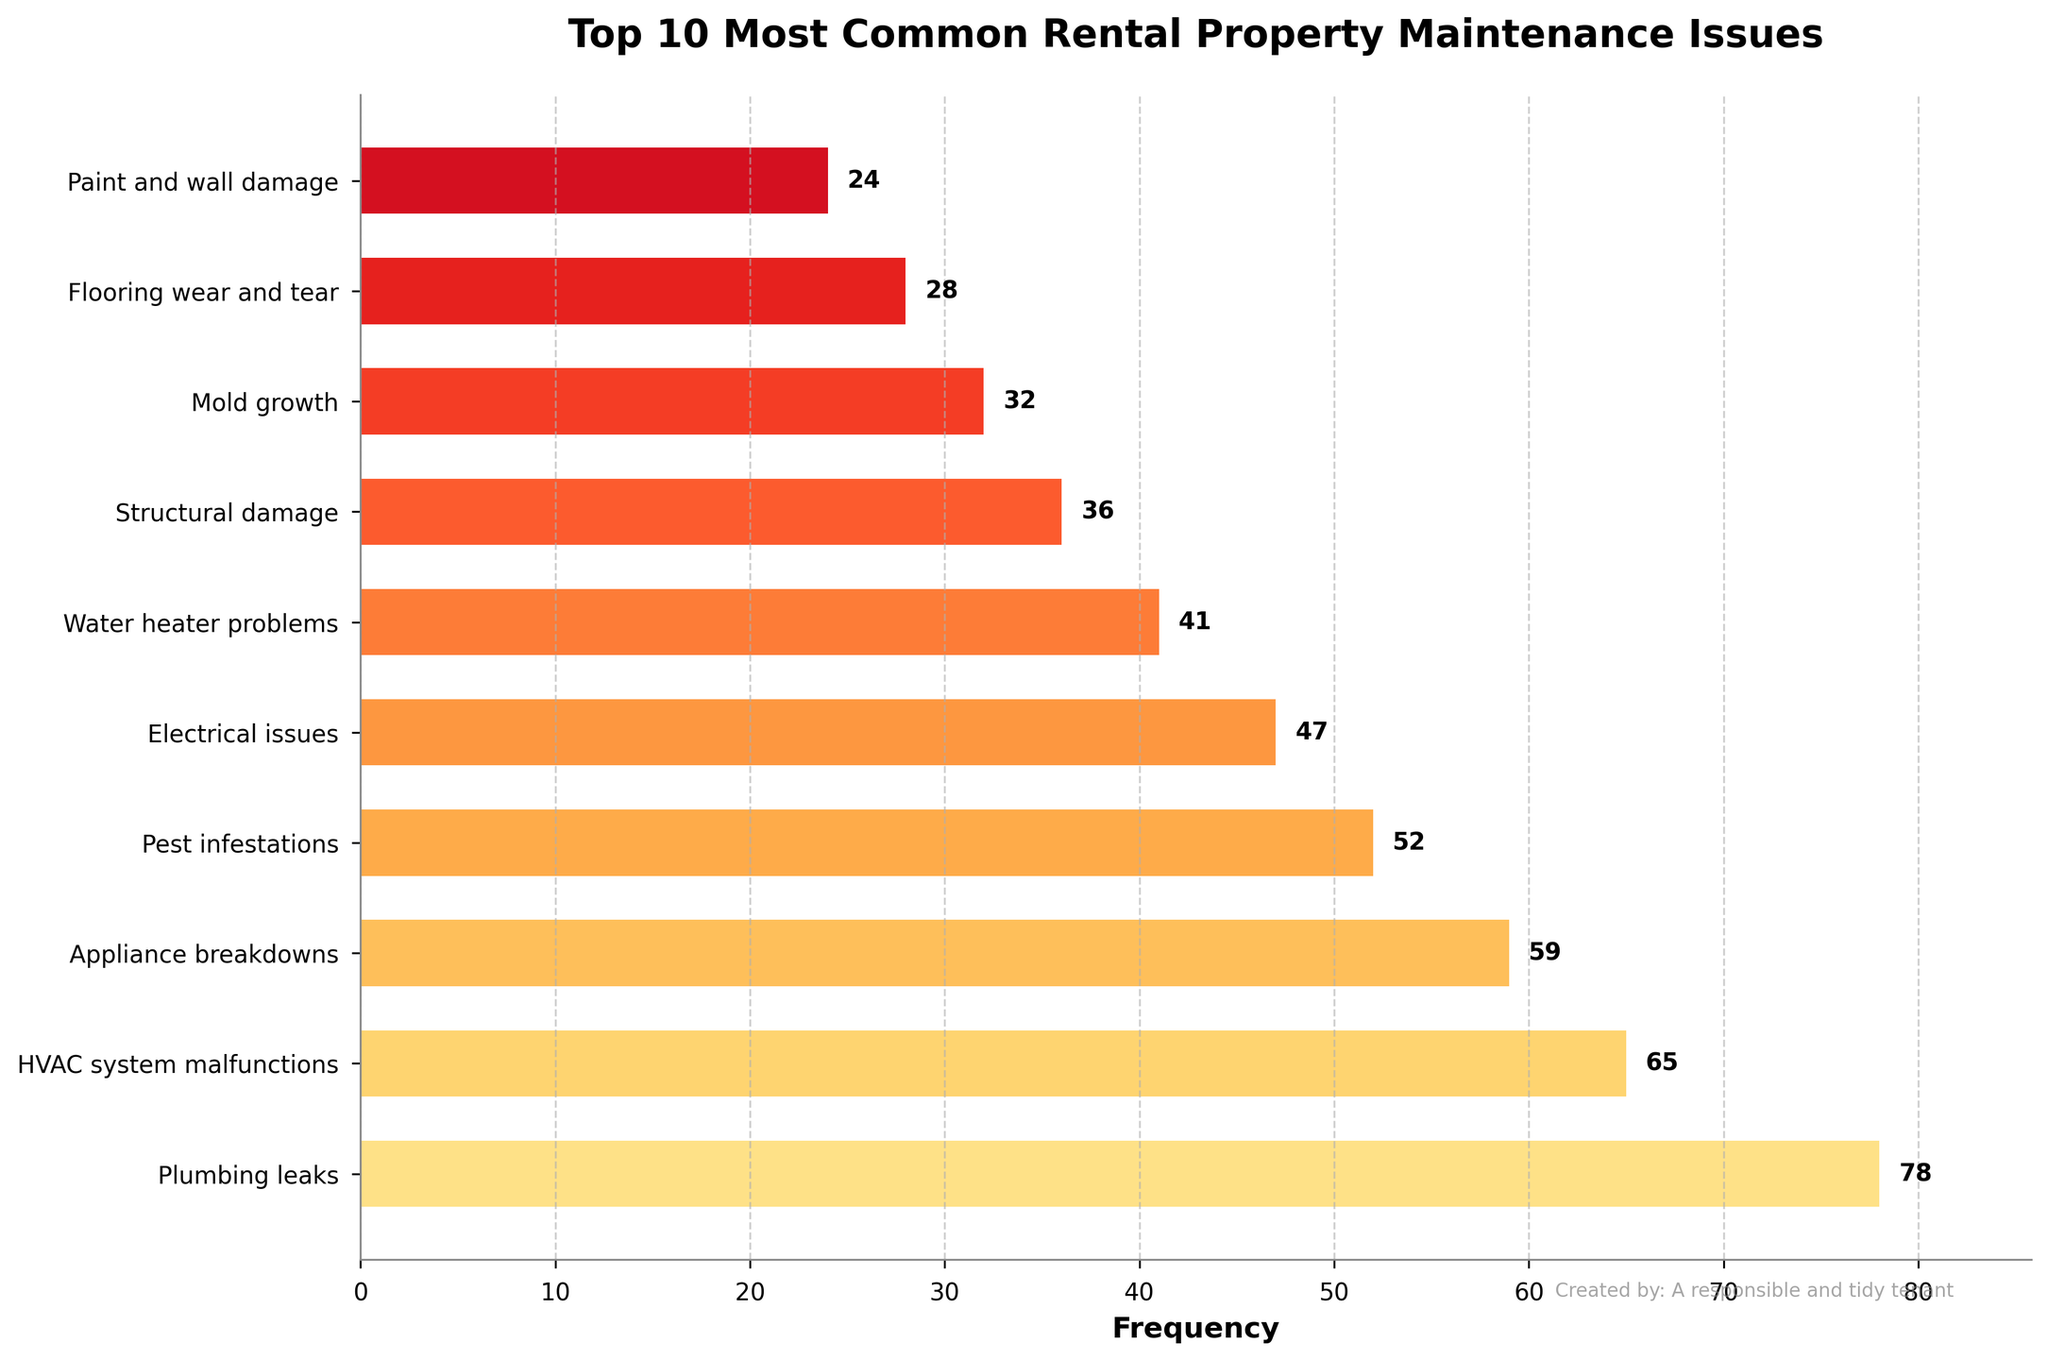What's the most common rental property maintenance issue? Identify the tallest bar in the figure. The label on the y-axis corresponding to this bar represents the most common issue.
Answer: Plumbing leaks Which maintenance issue occurs the least often among the top 10? Find the shortest bar in the figure. The label on the y-axis corresponding to this bar represents the least common issue.
Answer: Paint and wall damage How many more times do plumbing leaks happen compared to electrical issues? Find the height of the bar for plumbing leaks and the bar for electrical issues. Subtract the frequency of electrical issues from the frequency of plumbing leaks (78 - 47 = 31).
Answer: 31 What's the total frequency of the top 3 most common maintenance issues? Add the frequencies of the three tallest bars: Plumbing leaks (78), HVAC system malfunctions (65), and Appliance breakdowns (59). The total is 78 + 65 + 59 = 202.
Answer: 202 Which maintenance issue has a frequency close to 50? Look for the bar with a height that approximates 50. The frequency close to 50 is Pest infestations with a frequency of 52.
Answer: Pest infestations Are water heater problems more or less common than structural damage? Compare the heights of the bars for water heater problems and structural damage. Water heater problems have a height of 41, and structural damage has a height of 36.
Answer: More common By how much does the frequency of HVAC system malfunctions exceed the frequency of mold growth? Subtract the frequency of mold growth from the frequency of HVAC system malfunctions (65 - 32 = 33).
Answer: 33 What's the percentage of appliance breakdowns relative to the total frequency of all issues? First, sum up all the frequencies: 78 + 65 + 59 + 52 + 47 + 41 + 36 + 32 + 28 + 24 = 462. Then, calculate the percentage of appliance breakdowns: (59 / 462) * 100 ≈ 12.77%.
Answer: Approximately 12.77% Which issue has a higher frequency: appliance breakdowns or pest infestations, and by how much? Compare the heights of the bars for appliance breakdowns (59) and pest infestations (52). Subtract the smaller frequency from the larger frequency (59 - 52 = 7).
Answer: Appliance breakdowns by 7 